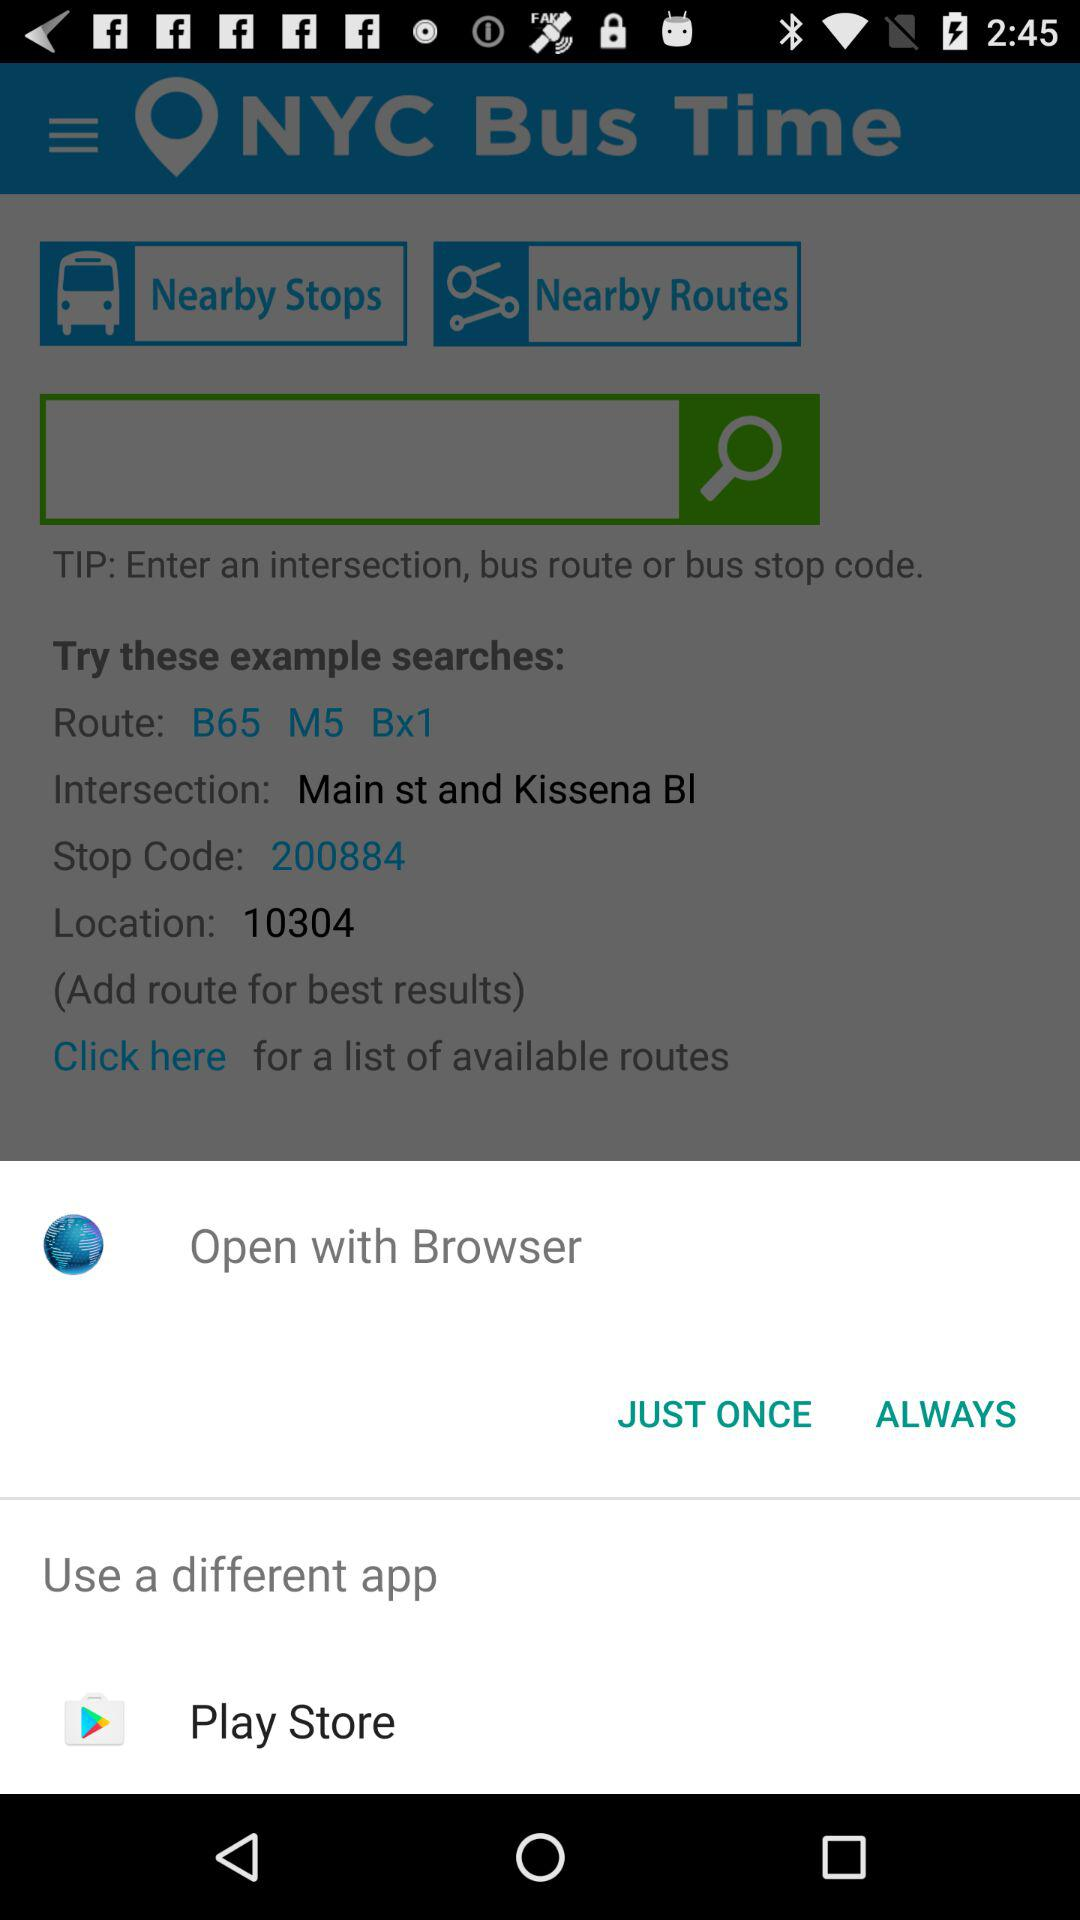What is the route number? The route number is "B65 M5 Bx1". 